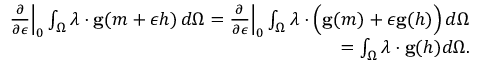<formula> <loc_0><loc_0><loc_500><loc_500>\begin{array} { r l r } & { \frac { \partial } { \partial \epsilon } \left | _ { 0 } \int _ { \Omega } \lambda \cdot g ( m + \epsilon h ) \, d \Omega = \frac { \partial } { \partial \epsilon } \right | _ { 0 } \int _ { \Omega } \lambda \cdot \left ( g ( m ) + \epsilon g ( h ) \right ) \, d \Omega } \\ & { = \int _ { \Omega } \lambda \cdot g ( h ) d \Omega . } \end{array}</formula> 